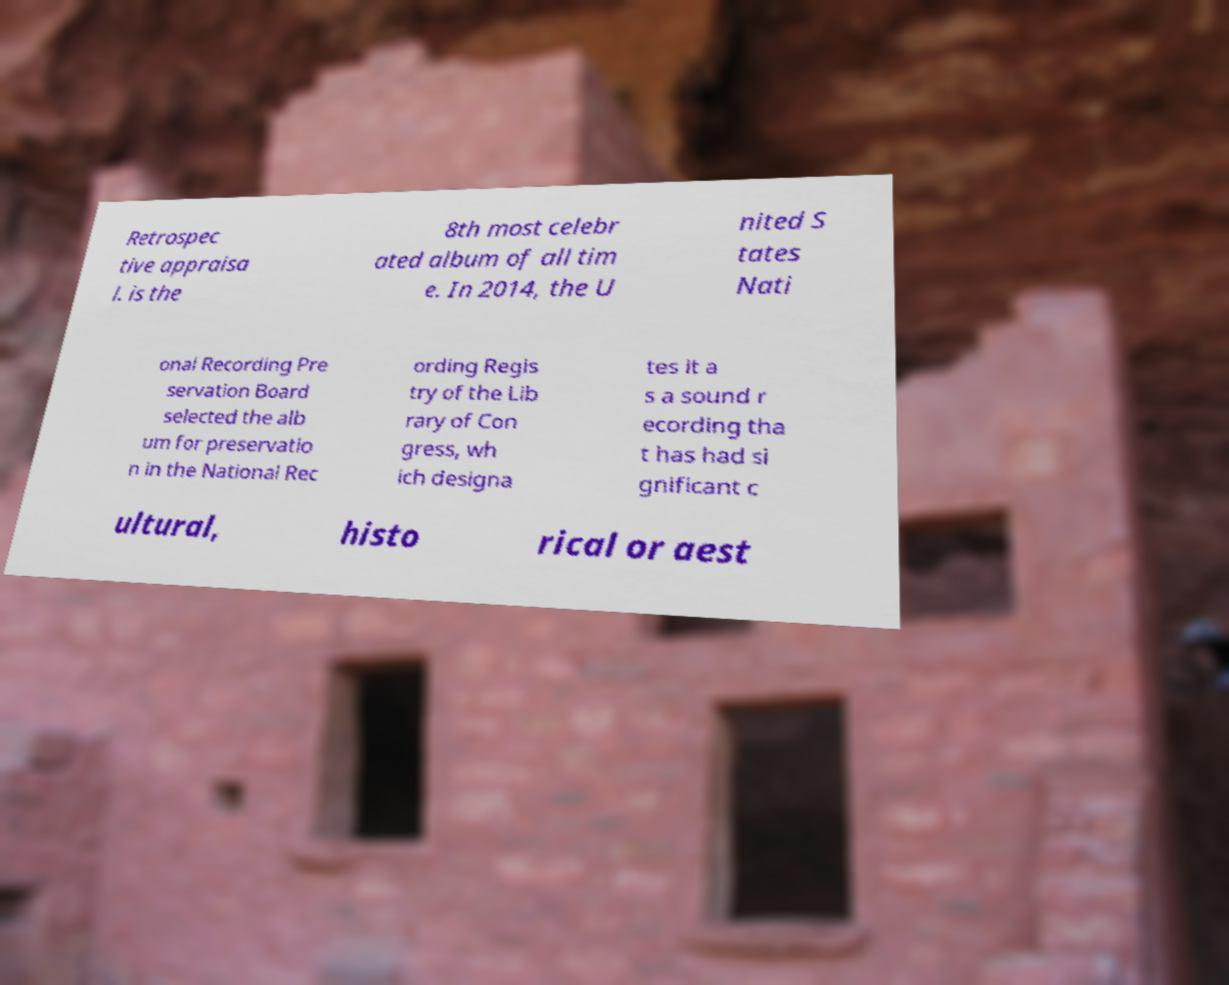Could you extract and type out the text from this image? Retrospec tive appraisa l. is the 8th most celebr ated album of all tim e. In 2014, the U nited S tates Nati onal Recording Pre servation Board selected the alb um for preservatio n in the National Rec ording Regis try of the Lib rary of Con gress, wh ich designa tes it a s a sound r ecording tha t has had si gnificant c ultural, histo rical or aest 